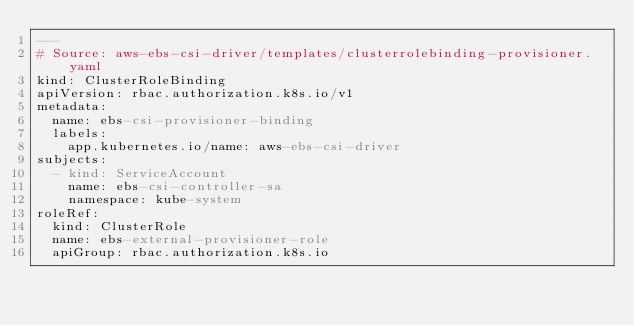<code> <loc_0><loc_0><loc_500><loc_500><_YAML_>---
# Source: aws-ebs-csi-driver/templates/clusterrolebinding-provisioner.yaml
kind: ClusterRoleBinding
apiVersion: rbac.authorization.k8s.io/v1
metadata:
  name: ebs-csi-provisioner-binding
  labels:
    app.kubernetes.io/name: aws-ebs-csi-driver
subjects:
  - kind: ServiceAccount
    name: ebs-csi-controller-sa
    namespace: kube-system
roleRef:
  kind: ClusterRole
  name: ebs-external-provisioner-role
  apiGroup: rbac.authorization.k8s.io
</code> 